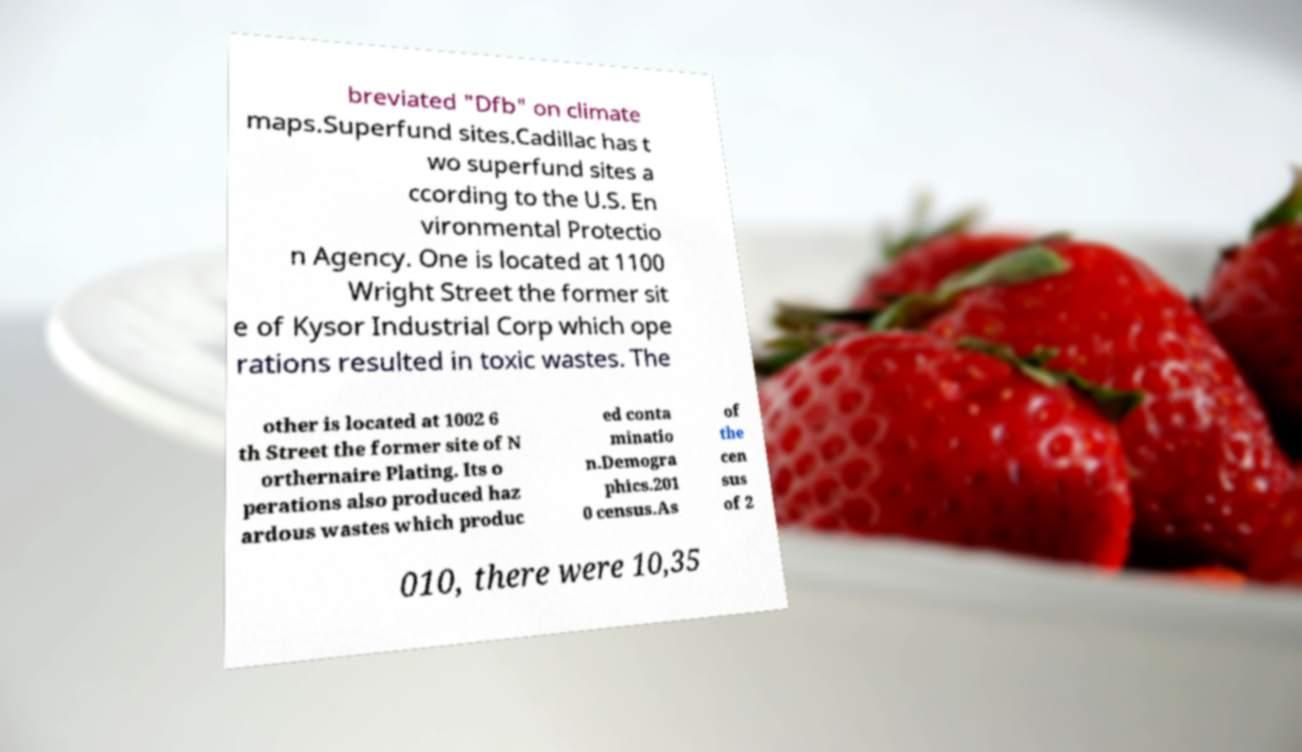I need the written content from this picture converted into text. Can you do that? breviated "Dfb" on climate maps.Superfund sites.Cadillac has t wo superfund sites a ccording to the U.S. En vironmental Protectio n Agency. One is located at 1100 Wright Street the former sit e of Kysor Industrial Corp which ope rations resulted in toxic wastes. The other is located at 1002 6 th Street the former site of N orthernaire Plating. Its o perations also produced haz ardous wastes which produc ed conta minatio n.Demogra phics.201 0 census.As of the cen sus of 2 010, there were 10,35 